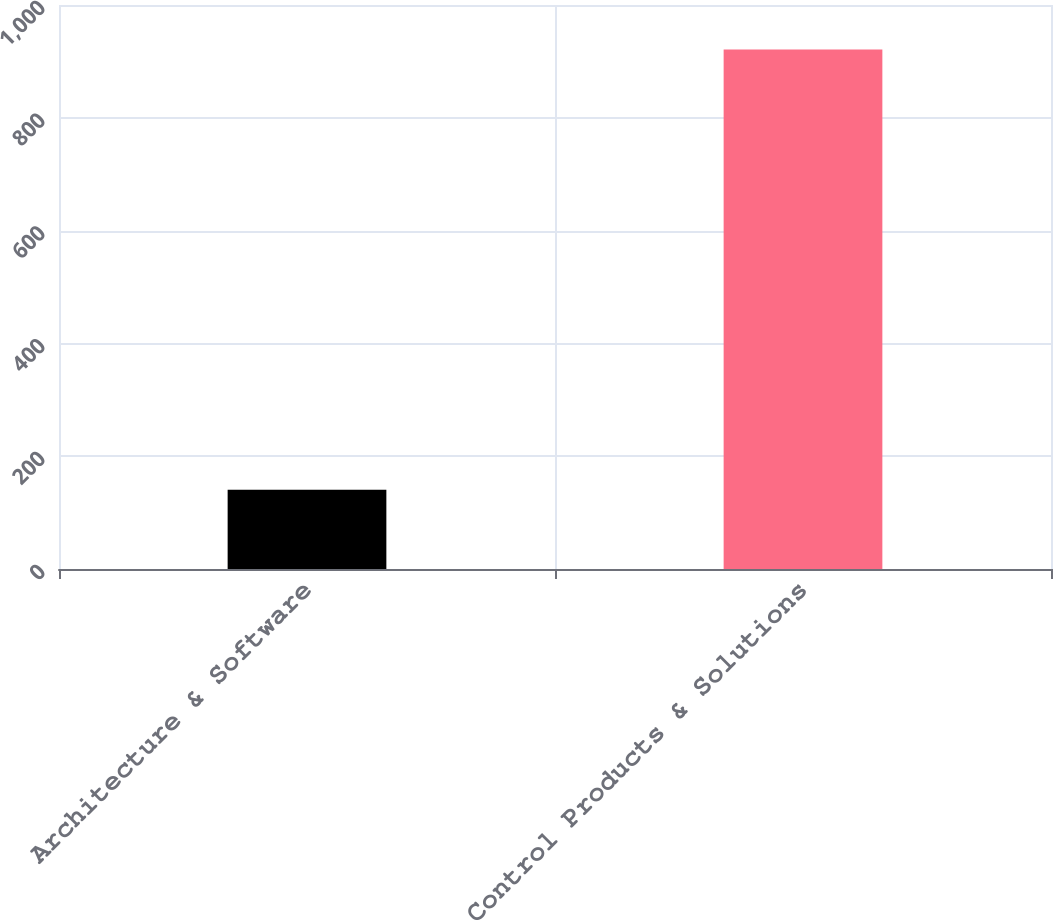<chart> <loc_0><loc_0><loc_500><loc_500><bar_chart><fcel>Architecture & Software<fcel>Control Products & Solutions<nl><fcel>140.6<fcel>921<nl></chart> 